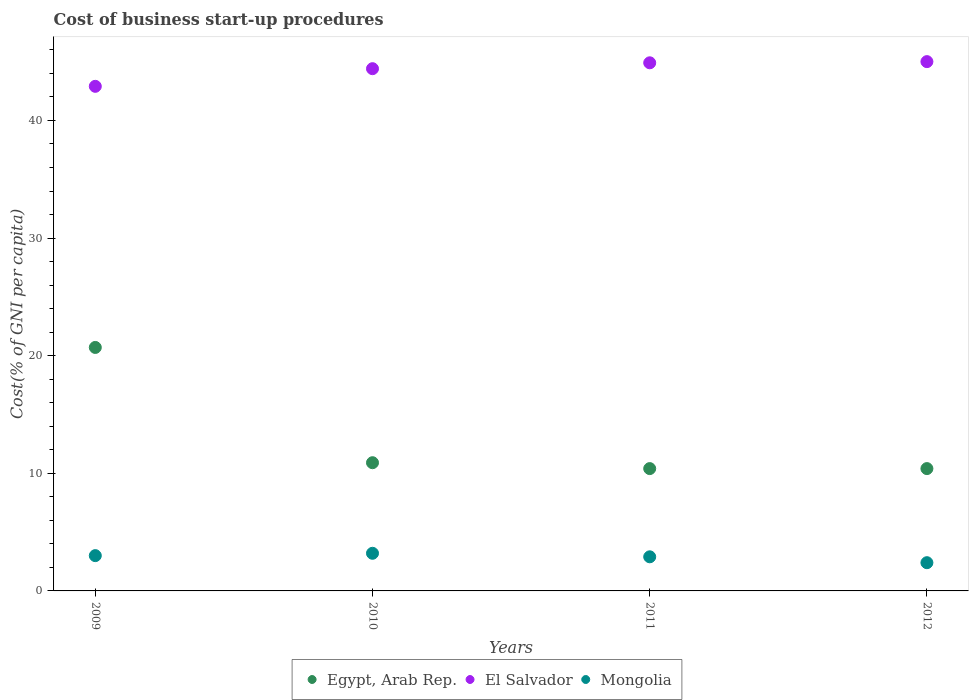What is the cost of business start-up procedures in El Salvador in 2009?
Offer a very short reply. 42.9. Across all years, what is the maximum cost of business start-up procedures in Egypt, Arab Rep.?
Keep it short and to the point. 20.7. Across all years, what is the minimum cost of business start-up procedures in Egypt, Arab Rep.?
Provide a succinct answer. 10.4. In which year was the cost of business start-up procedures in El Salvador minimum?
Ensure brevity in your answer.  2009. What is the difference between the cost of business start-up procedures in Mongolia in 2011 and the cost of business start-up procedures in Egypt, Arab Rep. in 2010?
Your answer should be very brief. -8. What is the average cost of business start-up procedures in El Salvador per year?
Make the answer very short. 44.3. In the year 2010, what is the difference between the cost of business start-up procedures in El Salvador and cost of business start-up procedures in Mongolia?
Keep it short and to the point. 41.2. What is the ratio of the cost of business start-up procedures in Egypt, Arab Rep. in 2009 to that in 2011?
Give a very brief answer. 1.99. What is the difference between the highest and the second highest cost of business start-up procedures in Egypt, Arab Rep.?
Your answer should be compact. 9.8. What is the difference between the highest and the lowest cost of business start-up procedures in Mongolia?
Your answer should be compact. 0.8. Is it the case that in every year, the sum of the cost of business start-up procedures in El Salvador and cost of business start-up procedures in Egypt, Arab Rep.  is greater than the cost of business start-up procedures in Mongolia?
Offer a terse response. Yes. Does the cost of business start-up procedures in Egypt, Arab Rep. monotonically increase over the years?
Offer a very short reply. No. Is the cost of business start-up procedures in Mongolia strictly greater than the cost of business start-up procedures in El Salvador over the years?
Offer a terse response. No. How many years are there in the graph?
Your response must be concise. 4. What is the difference between two consecutive major ticks on the Y-axis?
Ensure brevity in your answer.  10. Does the graph contain grids?
Ensure brevity in your answer.  No. Where does the legend appear in the graph?
Your response must be concise. Bottom center. What is the title of the graph?
Provide a short and direct response. Cost of business start-up procedures. Does "Greenland" appear as one of the legend labels in the graph?
Offer a very short reply. No. What is the label or title of the Y-axis?
Provide a short and direct response. Cost(% of GNI per capita). What is the Cost(% of GNI per capita) in Egypt, Arab Rep. in 2009?
Your answer should be compact. 20.7. What is the Cost(% of GNI per capita) in El Salvador in 2009?
Your answer should be compact. 42.9. What is the Cost(% of GNI per capita) of Mongolia in 2009?
Provide a succinct answer. 3. What is the Cost(% of GNI per capita) in Egypt, Arab Rep. in 2010?
Give a very brief answer. 10.9. What is the Cost(% of GNI per capita) in El Salvador in 2010?
Offer a very short reply. 44.4. What is the Cost(% of GNI per capita) of Mongolia in 2010?
Your answer should be very brief. 3.2. What is the Cost(% of GNI per capita) of Egypt, Arab Rep. in 2011?
Keep it short and to the point. 10.4. What is the Cost(% of GNI per capita) of El Salvador in 2011?
Make the answer very short. 44.9. What is the Cost(% of GNI per capita) in Egypt, Arab Rep. in 2012?
Provide a succinct answer. 10.4. What is the Cost(% of GNI per capita) in Mongolia in 2012?
Ensure brevity in your answer.  2.4. Across all years, what is the maximum Cost(% of GNI per capita) in Egypt, Arab Rep.?
Keep it short and to the point. 20.7. Across all years, what is the maximum Cost(% of GNI per capita) in El Salvador?
Your answer should be very brief. 45. Across all years, what is the minimum Cost(% of GNI per capita) of Egypt, Arab Rep.?
Provide a short and direct response. 10.4. Across all years, what is the minimum Cost(% of GNI per capita) in El Salvador?
Offer a very short reply. 42.9. Across all years, what is the minimum Cost(% of GNI per capita) in Mongolia?
Give a very brief answer. 2.4. What is the total Cost(% of GNI per capita) in Egypt, Arab Rep. in the graph?
Offer a terse response. 52.4. What is the total Cost(% of GNI per capita) in El Salvador in the graph?
Offer a terse response. 177.2. What is the total Cost(% of GNI per capita) of Mongolia in the graph?
Keep it short and to the point. 11.5. What is the difference between the Cost(% of GNI per capita) of El Salvador in 2009 and that in 2010?
Your answer should be compact. -1.5. What is the difference between the Cost(% of GNI per capita) in Mongolia in 2009 and that in 2010?
Offer a terse response. -0.2. What is the difference between the Cost(% of GNI per capita) of Egypt, Arab Rep. in 2009 and that in 2011?
Offer a terse response. 10.3. What is the difference between the Cost(% of GNI per capita) in El Salvador in 2009 and that in 2011?
Provide a short and direct response. -2. What is the difference between the Cost(% of GNI per capita) in El Salvador in 2009 and that in 2012?
Your answer should be compact. -2.1. What is the difference between the Cost(% of GNI per capita) of Mongolia in 2009 and that in 2012?
Your answer should be very brief. 0.6. What is the difference between the Cost(% of GNI per capita) in Egypt, Arab Rep. in 2010 and that in 2011?
Your answer should be compact. 0.5. What is the difference between the Cost(% of GNI per capita) in El Salvador in 2010 and that in 2011?
Your response must be concise. -0.5. What is the difference between the Cost(% of GNI per capita) in Egypt, Arab Rep. in 2010 and that in 2012?
Offer a very short reply. 0.5. What is the difference between the Cost(% of GNI per capita) in El Salvador in 2010 and that in 2012?
Offer a terse response. -0.6. What is the difference between the Cost(% of GNI per capita) in Egypt, Arab Rep. in 2011 and that in 2012?
Ensure brevity in your answer.  0. What is the difference between the Cost(% of GNI per capita) of Mongolia in 2011 and that in 2012?
Your answer should be very brief. 0.5. What is the difference between the Cost(% of GNI per capita) of Egypt, Arab Rep. in 2009 and the Cost(% of GNI per capita) of El Salvador in 2010?
Make the answer very short. -23.7. What is the difference between the Cost(% of GNI per capita) in El Salvador in 2009 and the Cost(% of GNI per capita) in Mongolia in 2010?
Your answer should be very brief. 39.7. What is the difference between the Cost(% of GNI per capita) in Egypt, Arab Rep. in 2009 and the Cost(% of GNI per capita) in El Salvador in 2011?
Provide a succinct answer. -24.2. What is the difference between the Cost(% of GNI per capita) in Egypt, Arab Rep. in 2009 and the Cost(% of GNI per capita) in El Salvador in 2012?
Make the answer very short. -24.3. What is the difference between the Cost(% of GNI per capita) of El Salvador in 2009 and the Cost(% of GNI per capita) of Mongolia in 2012?
Your answer should be compact. 40.5. What is the difference between the Cost(% of GNI per capita) in Egypt, Arab Rep. in 2010 and the Cost(% of GNI per capita) in El Salvador in 2011?
Offer a very short reply. -34. What is the difference between the Cost(% of GNI per capita) in Egypt, Arab Rep. in 2010 and the Cost(% of GNI per capita) in Mongolia in 2011?
Offer a terse response. 8. What is the difference between the Cost(% of GNI per capita) of El Salvador in 2010 and the Cost(% of GNI per capita) of Mongolia in 2011?
Your answer should be very brief. 41.5. What is the difference between the Cost(% of GNI per capita) of Egypt, Arab Rep. in 2010 and the Cost(% of GNI per capita) of El Salvador in 2012?
Your response must be concise. -34.1. What is the difference between the Cost(% of GNI per capita) of El Salvador in 2010 and the Cost(% of GNI per capita) of Mongolia in 2012?
Your answer should be very brief. 42. What is the difference between the Cost(% of GNI per capita) in Egypt, Arab Rep. in 2011 and the Cost(% of GNI per capita) in El Salvador in 2012?
Provide a short and direct response. -34.6. What is the difference between the Cost(% of GNI per capita) of Egypt, Arab Rep. in 2011 and the Cost(% of GNI per capita) of Mongolia in 2012?
Keep it short and to the point. 8. What is the difference between the Cost(% of GNI per capita) in El Salvador in 2011 and the Cost(% of GNI per capita) in Mongolia in 2012?
Ensure brevity in your answer.  42.5. What is the average Cost(% of GNI per capita) of El Salvador per year?
Your answer should be compact. 44.3. What is the average Cost(% of GNI per capita) of Mongolia per year?
Offer a very short reply. 2.88. In the year 2009, what is the difference between the Cost(% of GNI per capita) in Egypt, Arab Rep. and Cost(% of GNI per capita) in El Salvador?
Your answer should be compact. -22.2. In the year 2009, what is the difference between the Cost(% of GNI per capita) in Egypt, Arab Rep. and Cost(% of GNI per capita) in Mongolia?
Provide a succinct answer. 17.7. In the year 2009, what is the difference between the Cost(% of GNI per capita) in El Salvador and Cost(% of GNI per capita) in Mongolia?
Ensure brevity in your answer.  39.9. In the year 2010, what is the difference between the Cost(% of GNI per capita) in Egypt, Arab Rep. and Cost(% of GNI per capita) in El Salvador?
Provide a short and direct response. -33.5. In the year 2010, what is the difference between the Cost(% of GNI per capita) of Egypt, Arab Rep. and Cost(% of GNI per capita) of Mongolia?
Provide a succinct answer. 7.7. In the year 2010, what is the difference between the Cost(% of GNI per capita) of El Salvador and Cost(% of GNI per capita) of Mongolia?
Keep it short and to the point. 41.2. In the year 2011, what is the difference between the Cost(% of GNI per capita) of Egypt, Arab Rep. and Cost(% of GNI per capita) of El Salvador?
Provide a succinct answer. -34.5. In the year 2011, what is the difference between the Cost(% of GNI per capita) of Egypt, Arab Rep. and Cost(% of GNI per capita) of Mongolia?
Keep it short and to the point. 7.5. In the year 2012, what is the difference between the Cost(% of GNI per capita) of Egypt, Arab Rep. and Cost(% of GNI per capita) of El Salvador?
Your answer should be compact. -34.6. In the year 2012, what is the difference between the Cost(% of GNI per capita) of El Salvador and Cost(% of GNI per capita) of Mongolia?
Your answer should be very brief. 42.6. What is the ratio of the Cost(% of GNI per capita) in Egypt, Arab Rep. in 2009 to that in 2010?
Give a very brief answer. 1.9. What is the ratio of the Cost(% of GNI per capita) in El Salvador in 2009 to that in 2010?
Keep it short and to the point. 0.97. What is the ratio of the Cost(% of GNI per capita) of Mongolia in 2009 to that in 2010?
Make the answer very short. 0.94. What is the ratio of the Cost(% of GNI per capita) of Egypt, Arab Rep. in 2009 to that in 2011?
Your answer should be compact. 1.99. What is the ratio of the Cost(% of GNI per capita) of El Salvador in 2009 to that in 2011?
Make the answer very short. 0.96. What is the ratio of the Cost(% of GNI per capita) of Mongolia in 2009 to that in 2011?
Provide a succinct answer. 1.03. What is the ratio of the Cost(% of GNI per capita) of Egypt, Arab Rep. in 2009 to that in 2012?
Offer a terse response. 1.99. What is the ratio of the Cost(% of GNI per capita) of El Salvador in 2009 to that in 2012?
Offer a very short reply. 0.95. What is the ratio of the Cost(% of GNI per capita) in Egypt, Arab Rep. in 2010 to that in 2011?
Your answer should be compact. 1.05. What is the ratio of the Cost(% of GNI per capita) in El Salvador in 2010 to that in 2011?
Offer a terse response. 0.99. What is the ratio of the Cost(% of GNI per capita) in Mongolia in 2010 to that in 2011?
Ensure brevity in your answer.  1.1. What is the ratio of the Cost(% of GNI per capita) in Egypt, Arab Rep. in 2010 to that in 2012?
Provide a short and direct response. 1.05. What is the ratio of the Cost(% of GNI per capita) in El Salvador in 2010 to that in 2012?
Offer a terse response. 0.99. What is the ratio of the Cost(% of GNI per capita) of Mongolia in 2010 to that in 2012?
Your response must be concise. 1.33. What is the ratio of the Cost(% of GNI per capita) of Mongolia in 2011 to that in 2012?
Your answer should be very brief. 1.21. What is the difference between the highest and the second highest Cost(% of GNI per capita) of Mongolia?
Give a very brief answer. 0.2. What is the difference between the highest and the lowest Cost(% of GNI per capita) in Egypt, Arab Rep.?
Offer a very short reply. 10.3. What is the difference between the highest and the lowest Cost(% of GNI per capita) in Mongolia?
Provide a short and direct response. 0.8. 